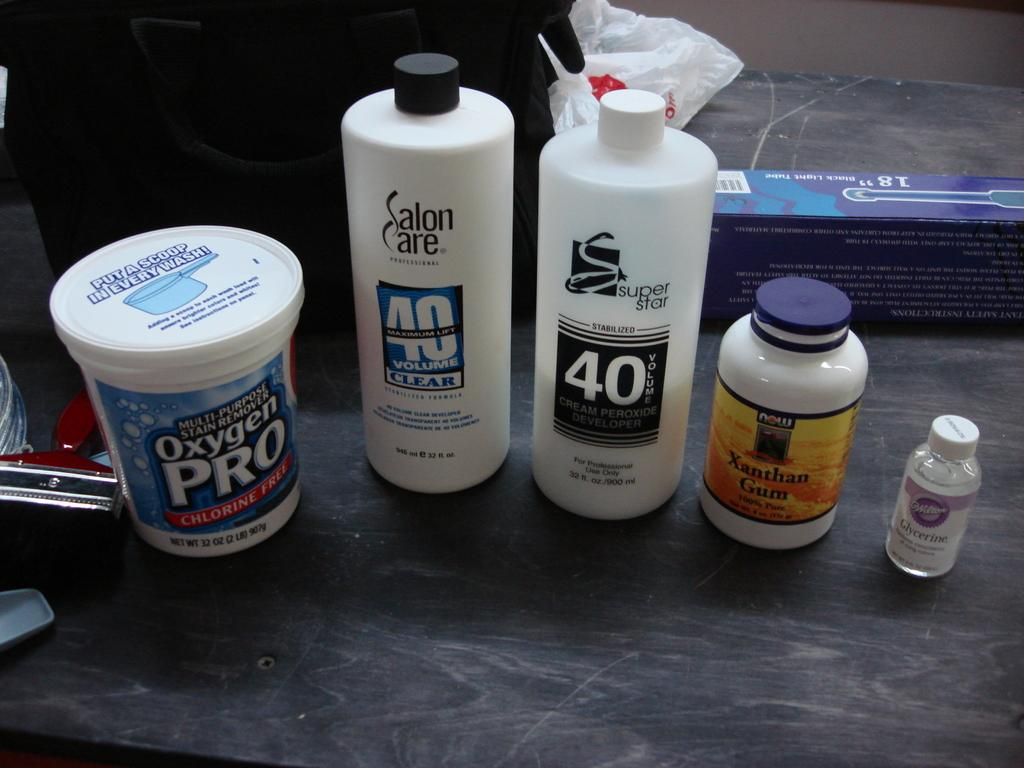<image>
Write a terse but informative summary of the picture. A group of products including a Salon Care product. 